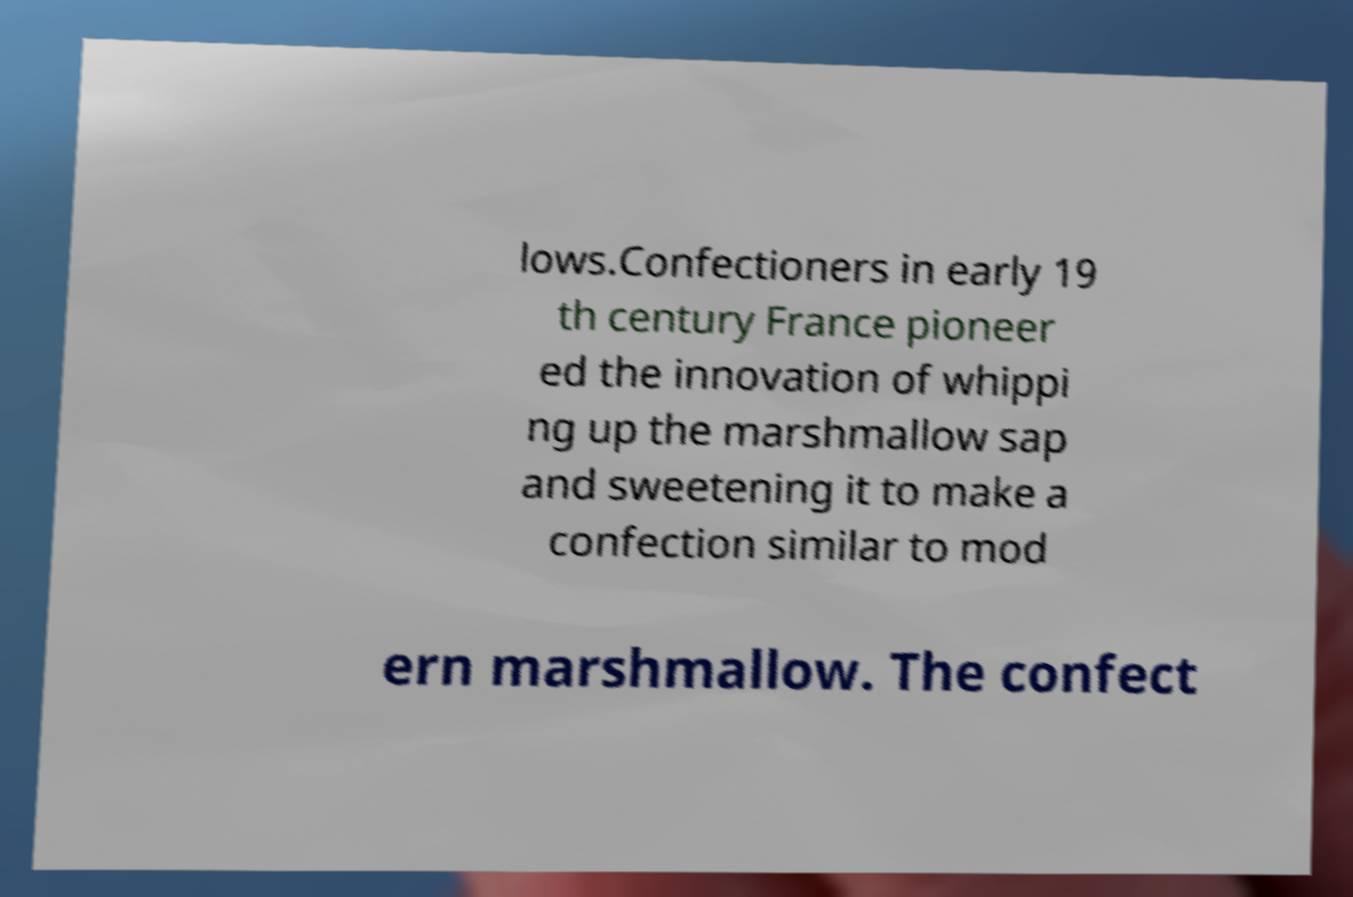Can you accurately transcribe the text from the provided image for me? lows.Confectioners in early 19 th century France pioneer ed the innovation of whippi ng up the marshmallow sap and sweetening it to make a confection similar to mod ern marshmallow. The confect 